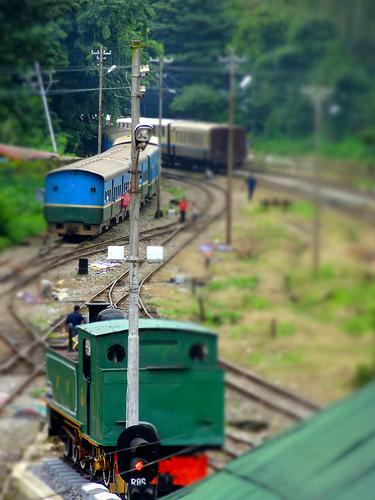Enumerate the elements related to the train tracks in the image. Rails, barriers, gravel, trash, green trees, and grey rocks. Describe the situation involving the people in the image? A person on the railway line, people standing on the track, a man behind the trains, and individuals wearing red and blue shirts. What are the primary attributes of the train and its cars? The train has windows, an open door, different colors like blue, green, brown, and red, and is metallic. What is the overall scene depicted in the image? The scene is at a railway crossway with multiple trains, people, and a pole with train signals. Mention the type and colors of shirts people are wearing in the image. People are wearing red and blue shirts in the image. Provide a brief description of the overall sentiment portrayed in the image. The image portrays an interesting scene at a railway crossway, with colorful trains and people, creating a lively atmosphere. Identify the different toy elements in the image. A toy model train set, figurine of a train worker, figures of people wearing red and blue shirts, a toy light pole, a toy train crossing sign, and train tracks for the toy train. List the different colors of trains mentioned in the image. Blue, green, brown, and red. What are the main features of the pole in the image? The pole is straight, metallic, has wires, train signals, and the light plates are black. Identify the primary objects in the image and their colors. The primary objects are a blue train, a green train car, a red and a blue shirt on people, and a metallic pole. Can you find a dog near the train tracks? None of the captions mention a dog, so it is misleading to ask the viewer to look for one. Is there a yellow train on the tracks? No captions mention a yellow train; they only mention blue, green, and brown trains. Is the grass pink in color? One caption mentions grass, but it does not mention the color. Therefore, it is misleading to assume it is pink. Can you see a person wearing a purple shirt? There are captions about people wearing blue and red shirts, but none mention a person wearing a purple shirt. Is there a sign that says "Stop" on the pole? While there is a mention of a train crossing sign and a pole, there is no specific information about the sign saying "Stop." Are there any unicorns on the railway line? None of the captions mention the presence of any unicorns on the railway line or anywhere else in the image. 